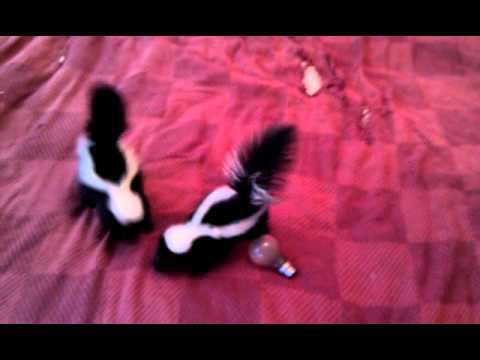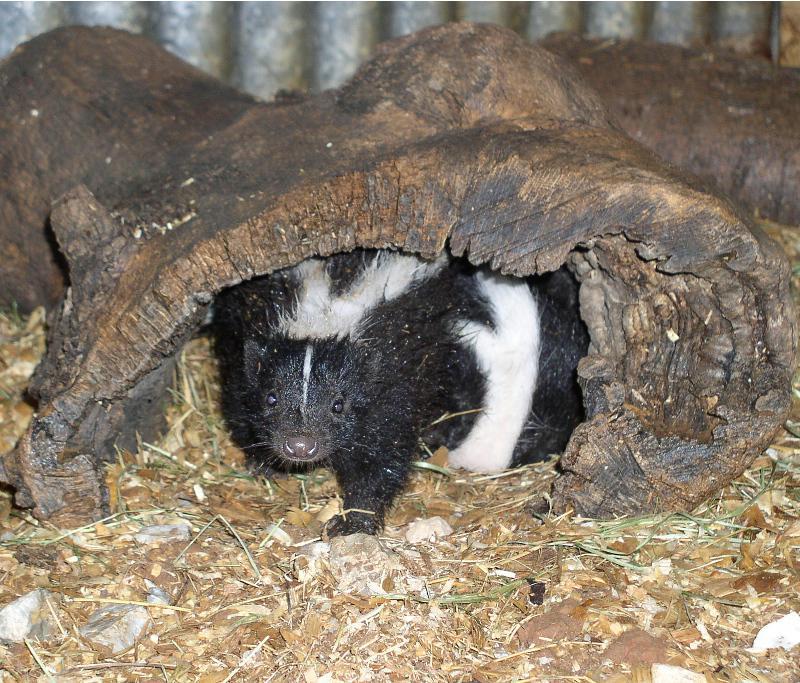The first image is the image on the left, the second image is the image on the right. For the images shown, is this caption "One image shows a reclining mother cat with a kitten and a skunk in front of it." true? Answer yes or no. No. The first image is the image on the left, the second image is the image on the right. Assess this claim about the two images: "There is more than one species of animal.". Correct or not? Answer yes or no. No. 